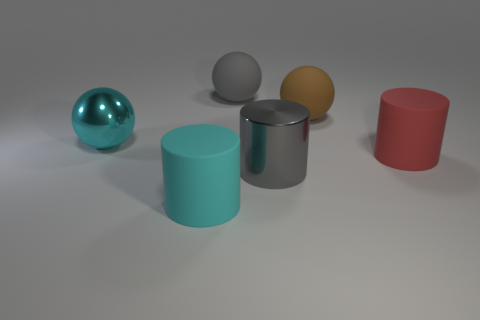How big is the brown thing on the right side of the large gray object that is behind the cyan metal ball?
Make the answer very short. Large. There is a cyan object that is in front of the matte cylinder on the right side of the rubber cylinder that is left of the big gray rubber object; what size is it?
Offer a very short reply. Large. Is the number of big red rubber objects in front of the large cyan matte cylinder the same as the number of big yellow matte blocks?
Provide a succinct answer. Yes. Is there anything else that has the same shape as the cyan metallic thing?
Your answer should be very brief. Yes. There is a brown matte thing; is it the same shape as the large gray thing in front of the big brown ball?
Your answer should be very brief. No. There is a cyan object that is the same shape as the large gray metal thing; what size is it?
Offer a very short reply. Large. How many other things are there of the same material as the large gray cylinder?
Offer a very short reply. 1. What is the big red object made of?
Offer a terse response. Rubber. Do the big rubber object in front of the red rubber object and the metallic object that is behind the red matte object have the same color?
Your answer should be compact. Yes. Are there more brown things behind the big gray matte sphere than cyan cylinders?
Offer a terse response. No. 